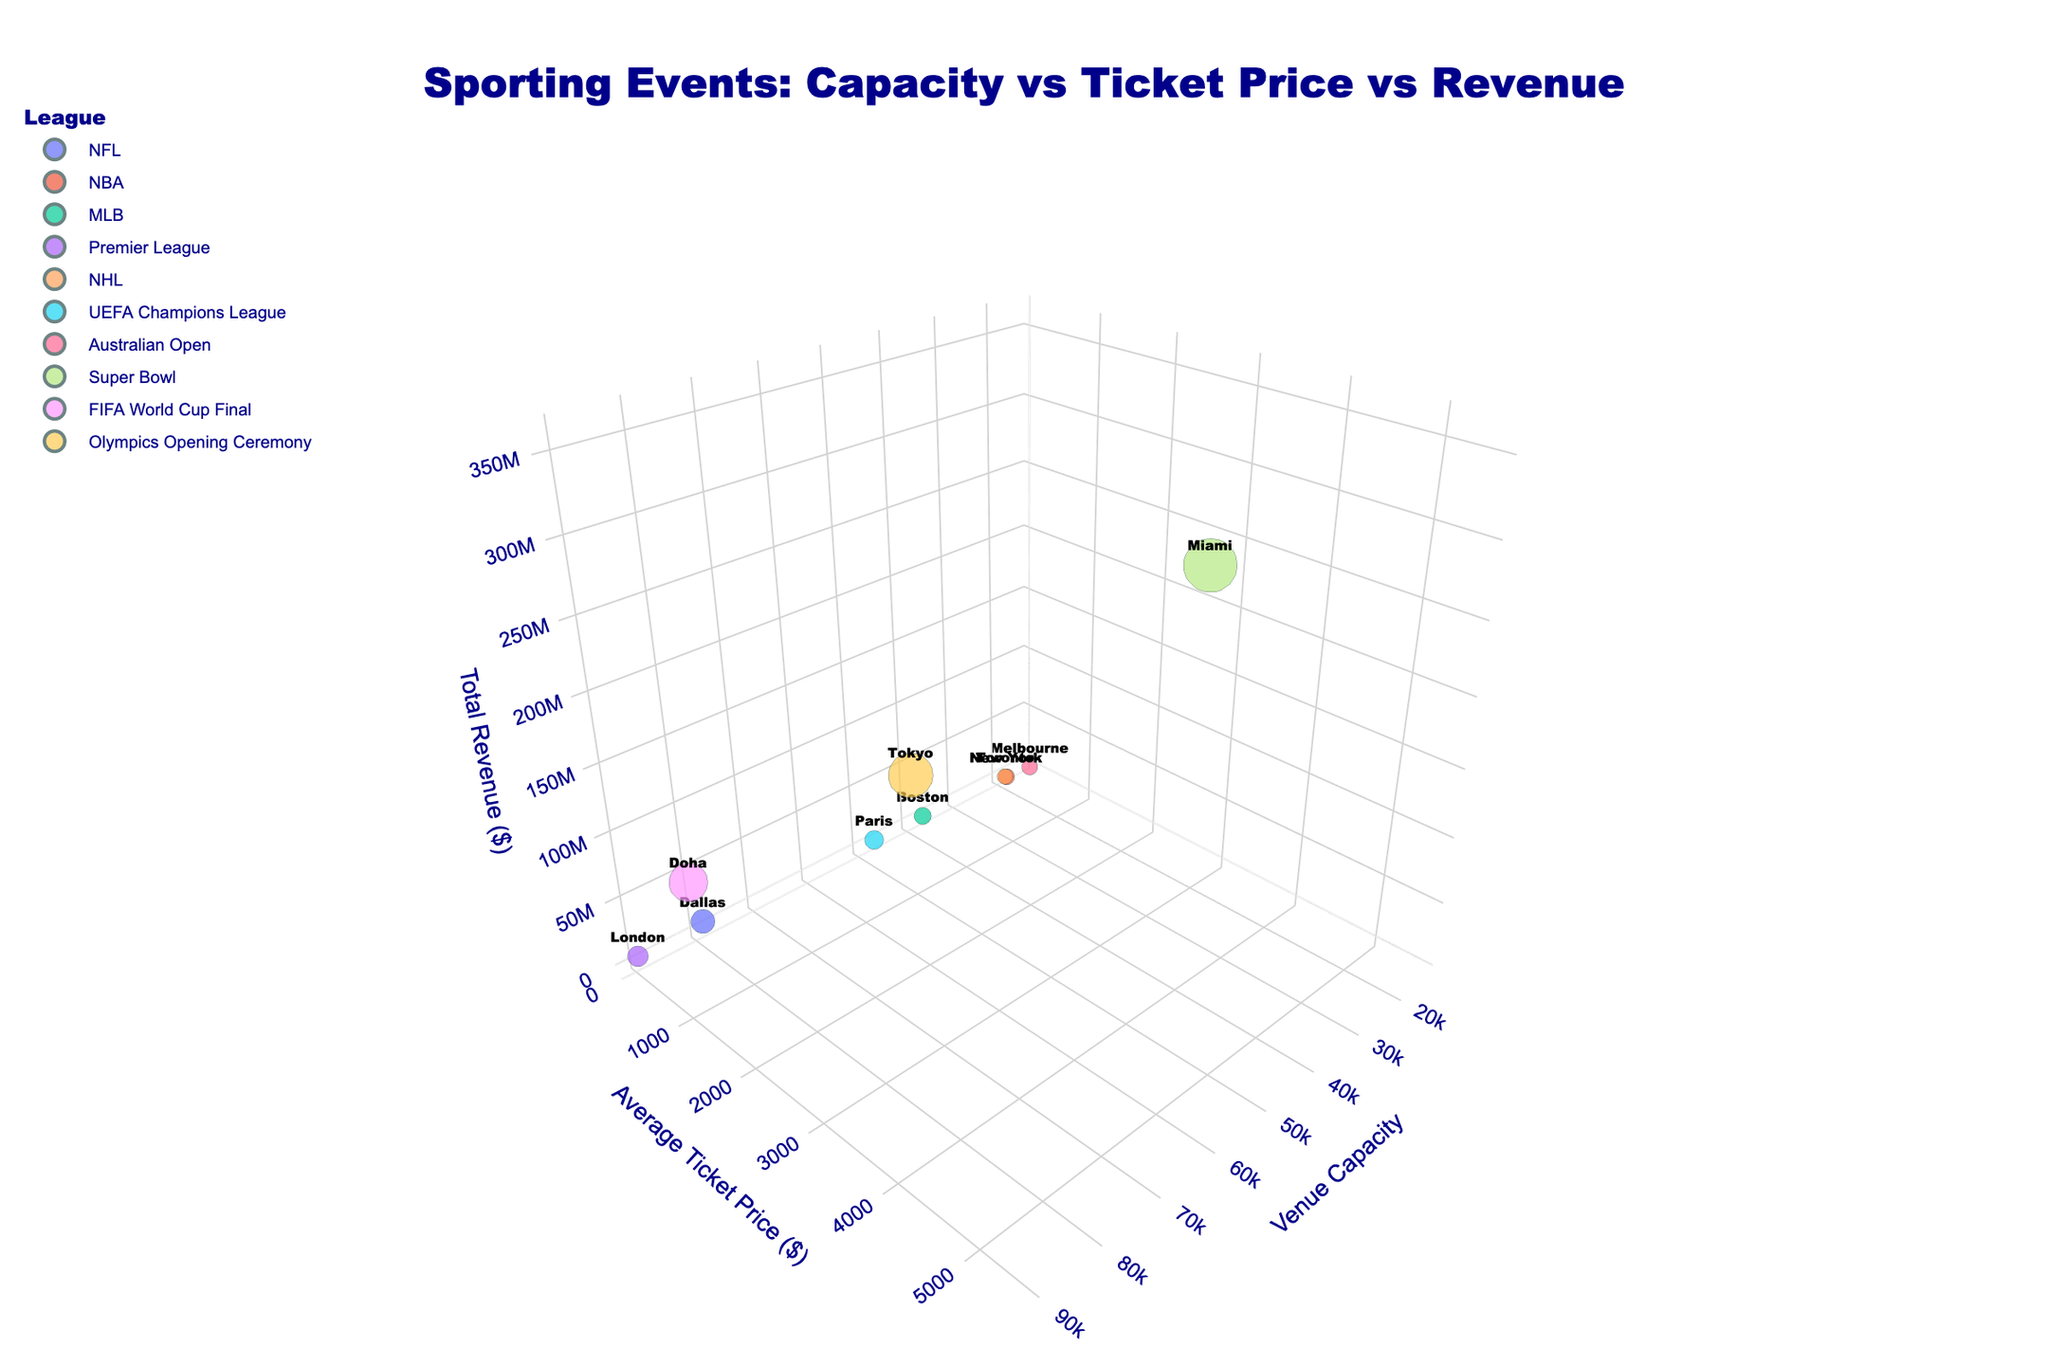What's the title of the 3D bubble chart? The title is displayed prominently at the top of the chart in large, bold, dark blue font. It summarizes what the chart is about.
Answer: Sporting Events: Capacity vs Ticket Price vs Revenue Which event has the highest ticket price? By looking at the y-axis (Average Ticket Price) and identifying the highest point, we can see which event corresponds to it.
Answer: Super Bowl How many events are represented by bubbles on the chart? Count the number of bubbles visible in the 3D space to determine the number of unique events.
Answer: 10 What's the relationship between venue capacity and total revenue for the Super Bowl? Locate the Super Bowl bubble and compare its x-axis (Venue Capacity) and z-axis (Total Revenue) values to see the relationship. The bigger the bubble, the higher the revenue, regardless of capacity.
Answer: High revenue despite medium capacity Which city has the event with the lowest average ticket price? Find the bubble at the lowest point on the y-axis and check the corresponding city from the hover or label information.
Answer: London What is the average venue capacity of the events in the chart? Sum the capacities of all venues and divide by the total number of events: (80000 + 19812 + 37731 + 90000 + 19800 + 47929 + 14820 + 65326 + 88966 + 68000) / 10.
Answer: 53238.4 Which league has the largest bubble size? Bubbles' sizes reflect total revenue; find the largest bubble by visual comparison, then check the league it represents.
Answer: Super Bowl (NFL) How does the capacity of AT&T Stadium compare to the Japan National Stadium? Locate the respective bubbles and compare their positions on the x-axis (Venue Capacity).
Answer: AT&T Stadium has a larger capacity Which event in Europe generates the highest revenue? Identify bubbles corresponding to European cities and check their z-axis values (Total Revenue).
Answer: FIFA World Cup Final in Doha What's the trend between average ticket price and total revenue for the events? Observe the y-axis for Average Ticket Price and the z-axis for Total Revenue; generally, bubbles with higher ticket prices tend to have higher revenues.
Answer: Higher ticket prices generally lead to higher revenues 